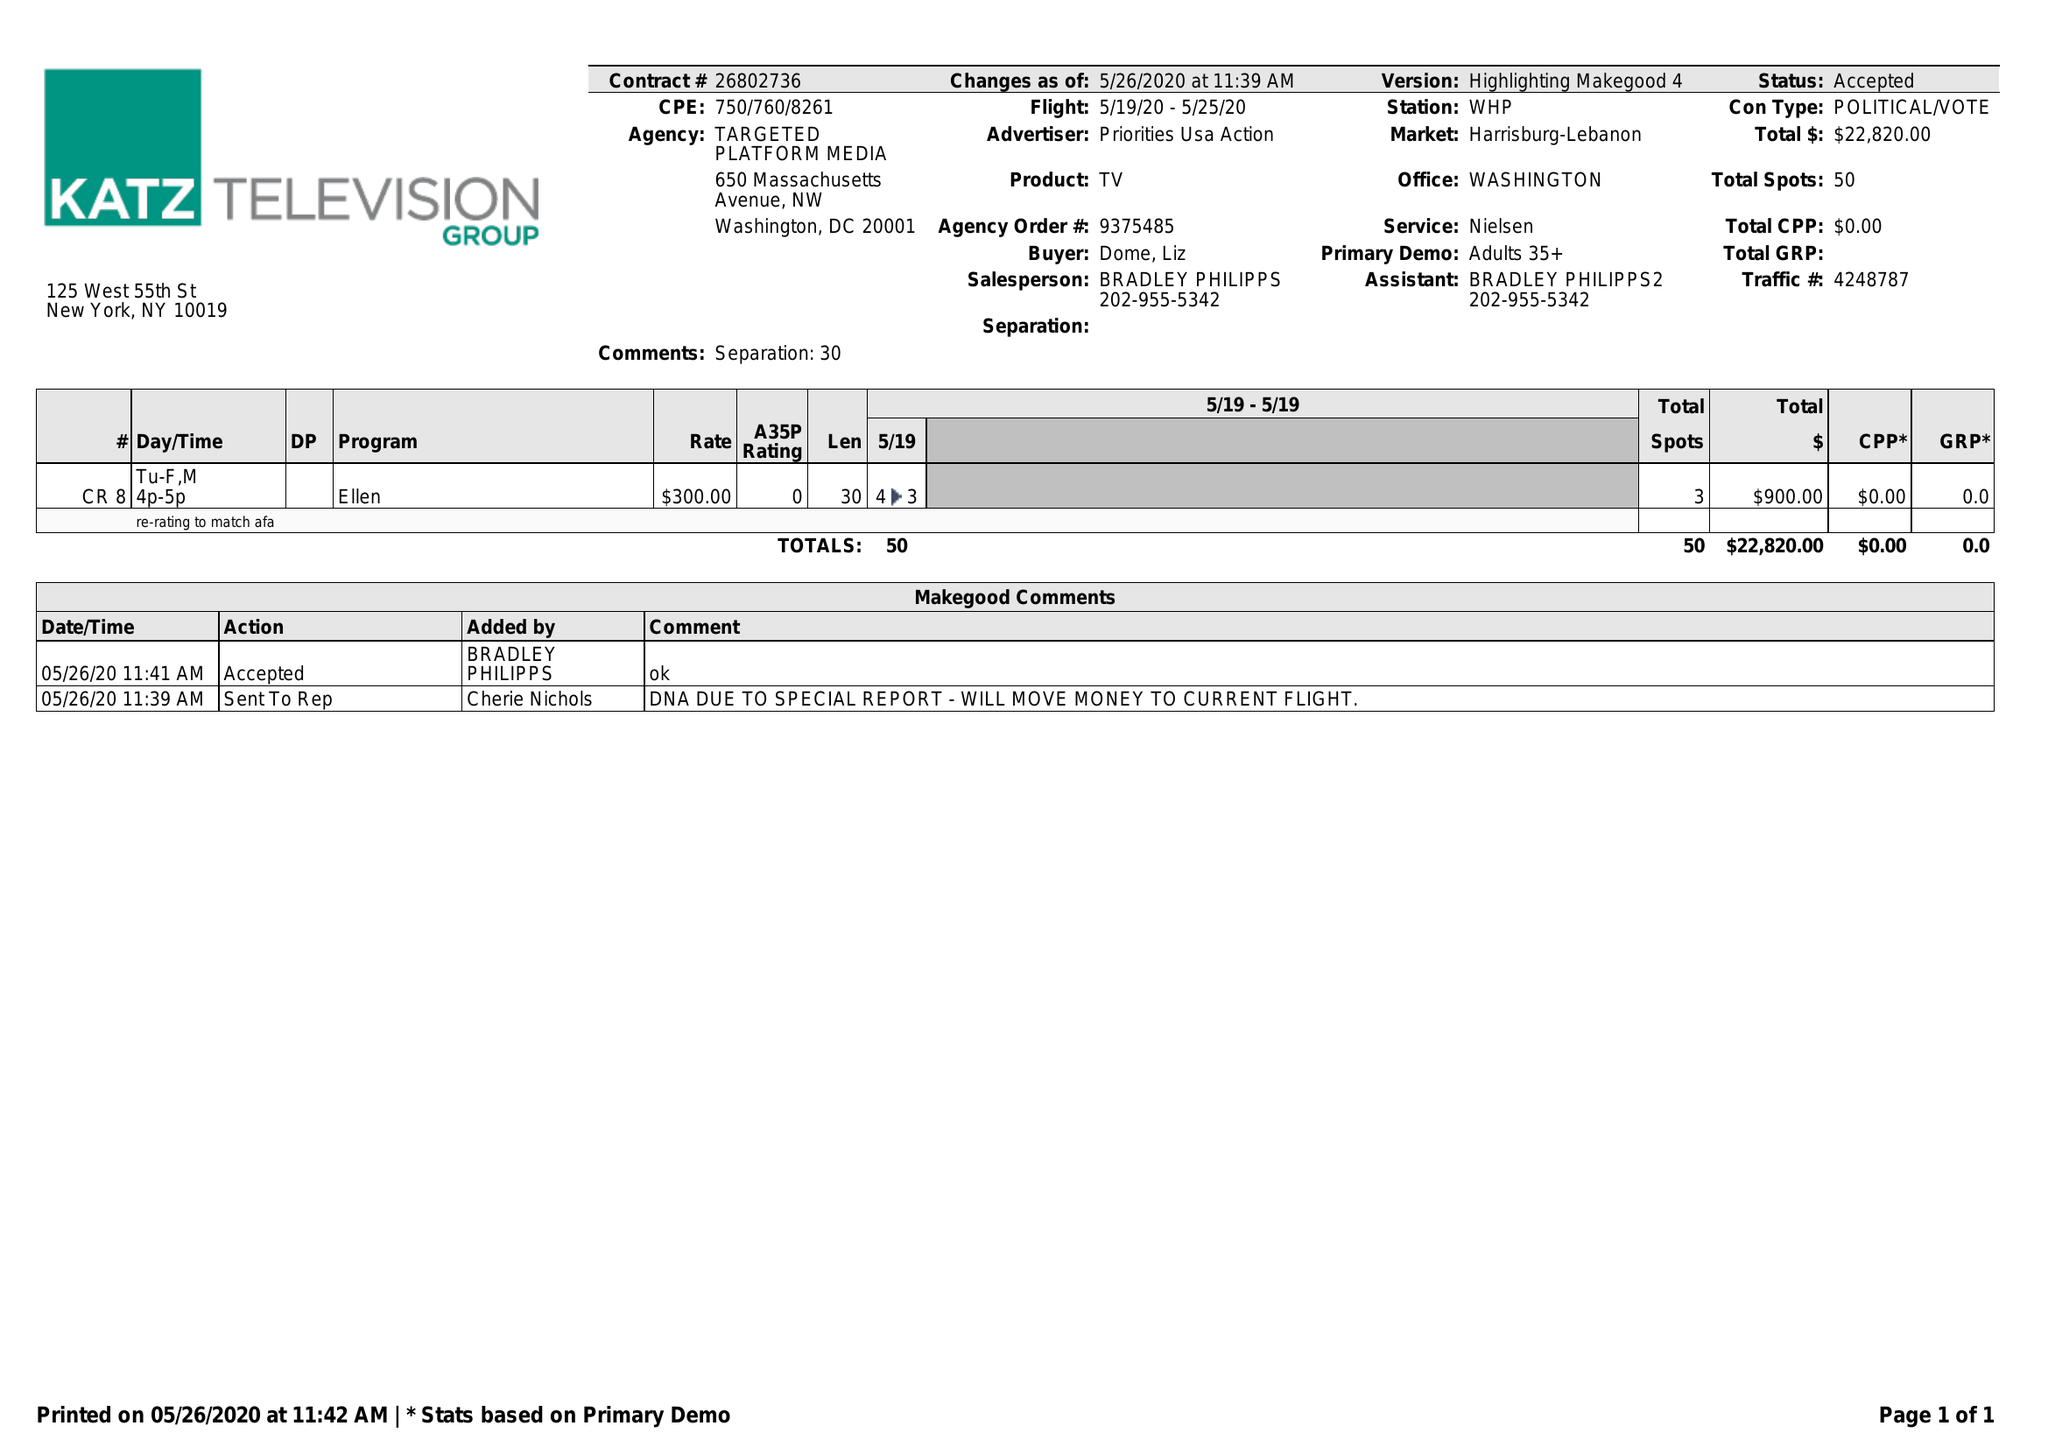What is the value for the gross_amount?
Answer the question using a single word or phrase. 22820.00 